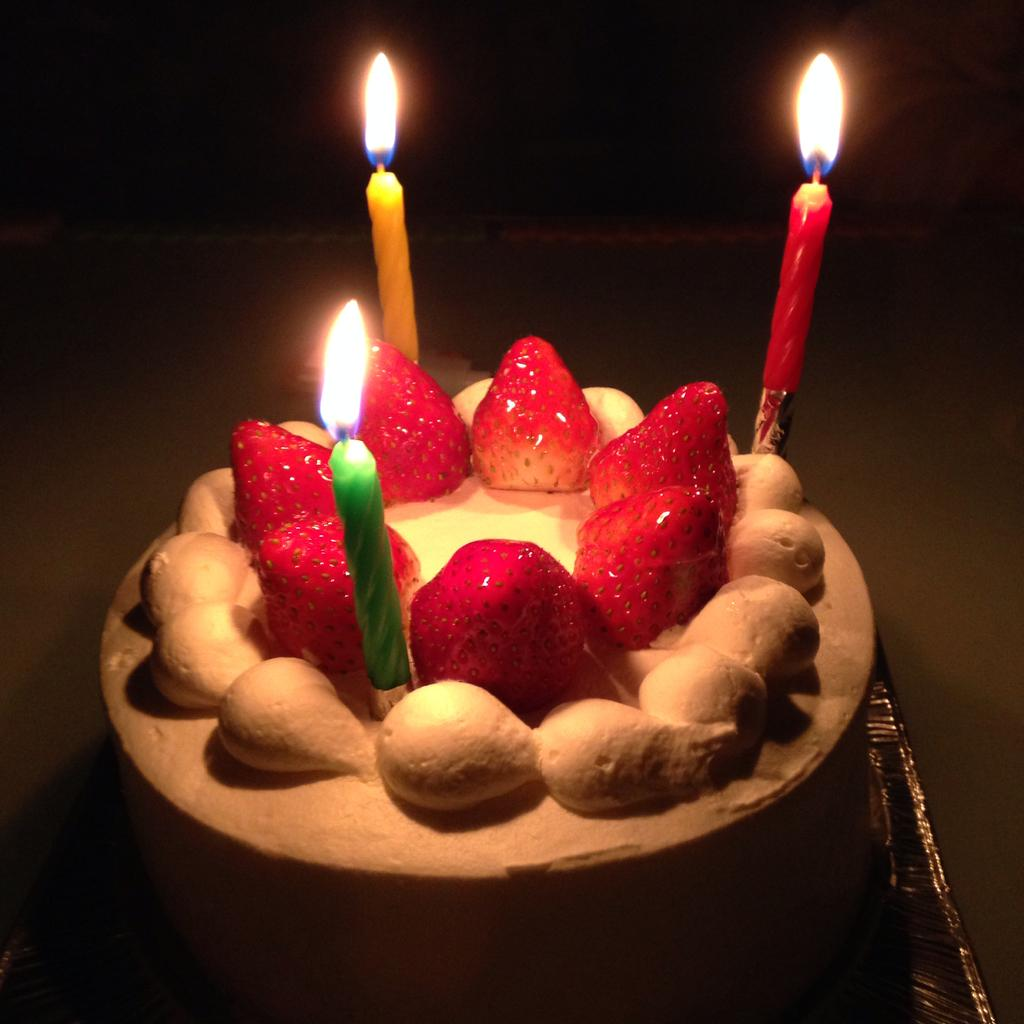What is the main subject of the image? There is a cake in the image. What decorations are on the cake? There are strawberries on the cake. How many candles are on the cake? There are 3 candles on the cake. Can you describe the background of the image? The background of the image appears to be dark. Is there any dirt visible on the cake in the image? No, there is no dirt visible on the cake in the image. What occasion might the cake be celebrating, given the presence of candles? The presence of candles on the cake suggests a birthday celebration, but the image itself does not provide any explicit information about the occasion. 